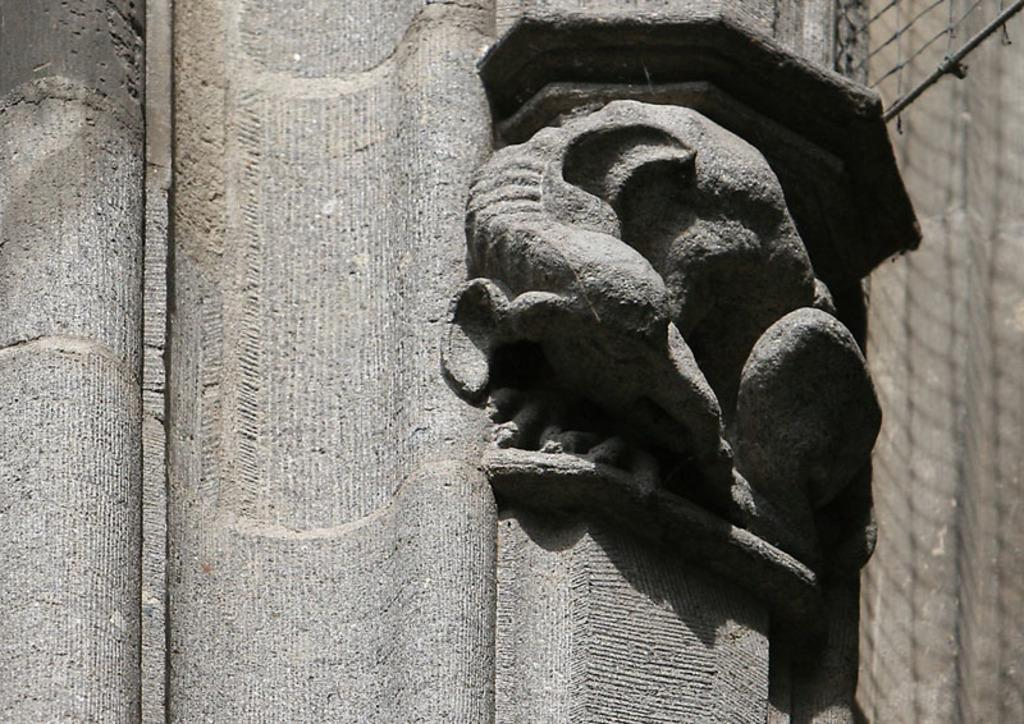What is the main subject in the image? There is a statue in the image. Where is the statue located in relation to other objects? The statue is near a wall. What is the color of the wall? The wall is in gray color. What type of stove can be seen in the image? There is no stove present in the image. 